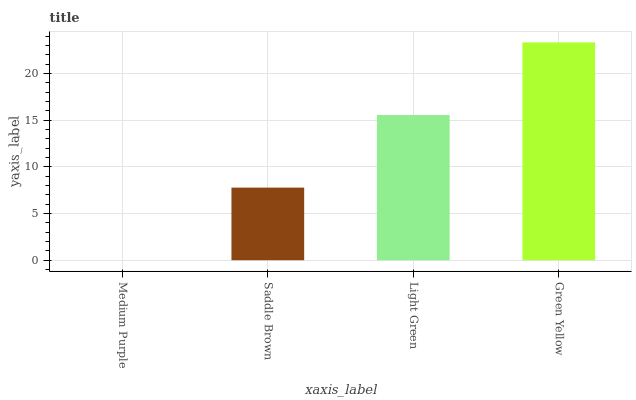Is Medium Purple the minimum?
Answer yes or no. Yes. Is Green Yellow the maximum?
Answer yes or no. Yes. Is Saddle Brown the minimum?
Answer yes or no. No. Is Saddle Brown the maximum?
Answer yes or no. No. Is Saddle Brown greater than Medium Purple?
Answer yes or no. Yes. Is Medium Purple less than Saddle Brown?
Answer yes or no. Yes. Is Medium Purple greater than Saddle Brown?
Answer yes or no. No. Is Saddle Brown less than Medium Purple?
Answer yes or no. No. Is Light Green the high median?
Answer yes or no. Yes. Is Saddle Brown the low median?
Answer yes or no. Yes. Is Green Yellow the high median?
Answer yes or no. No. Is Medium Purple the low median?
Answer yes or no. No. 